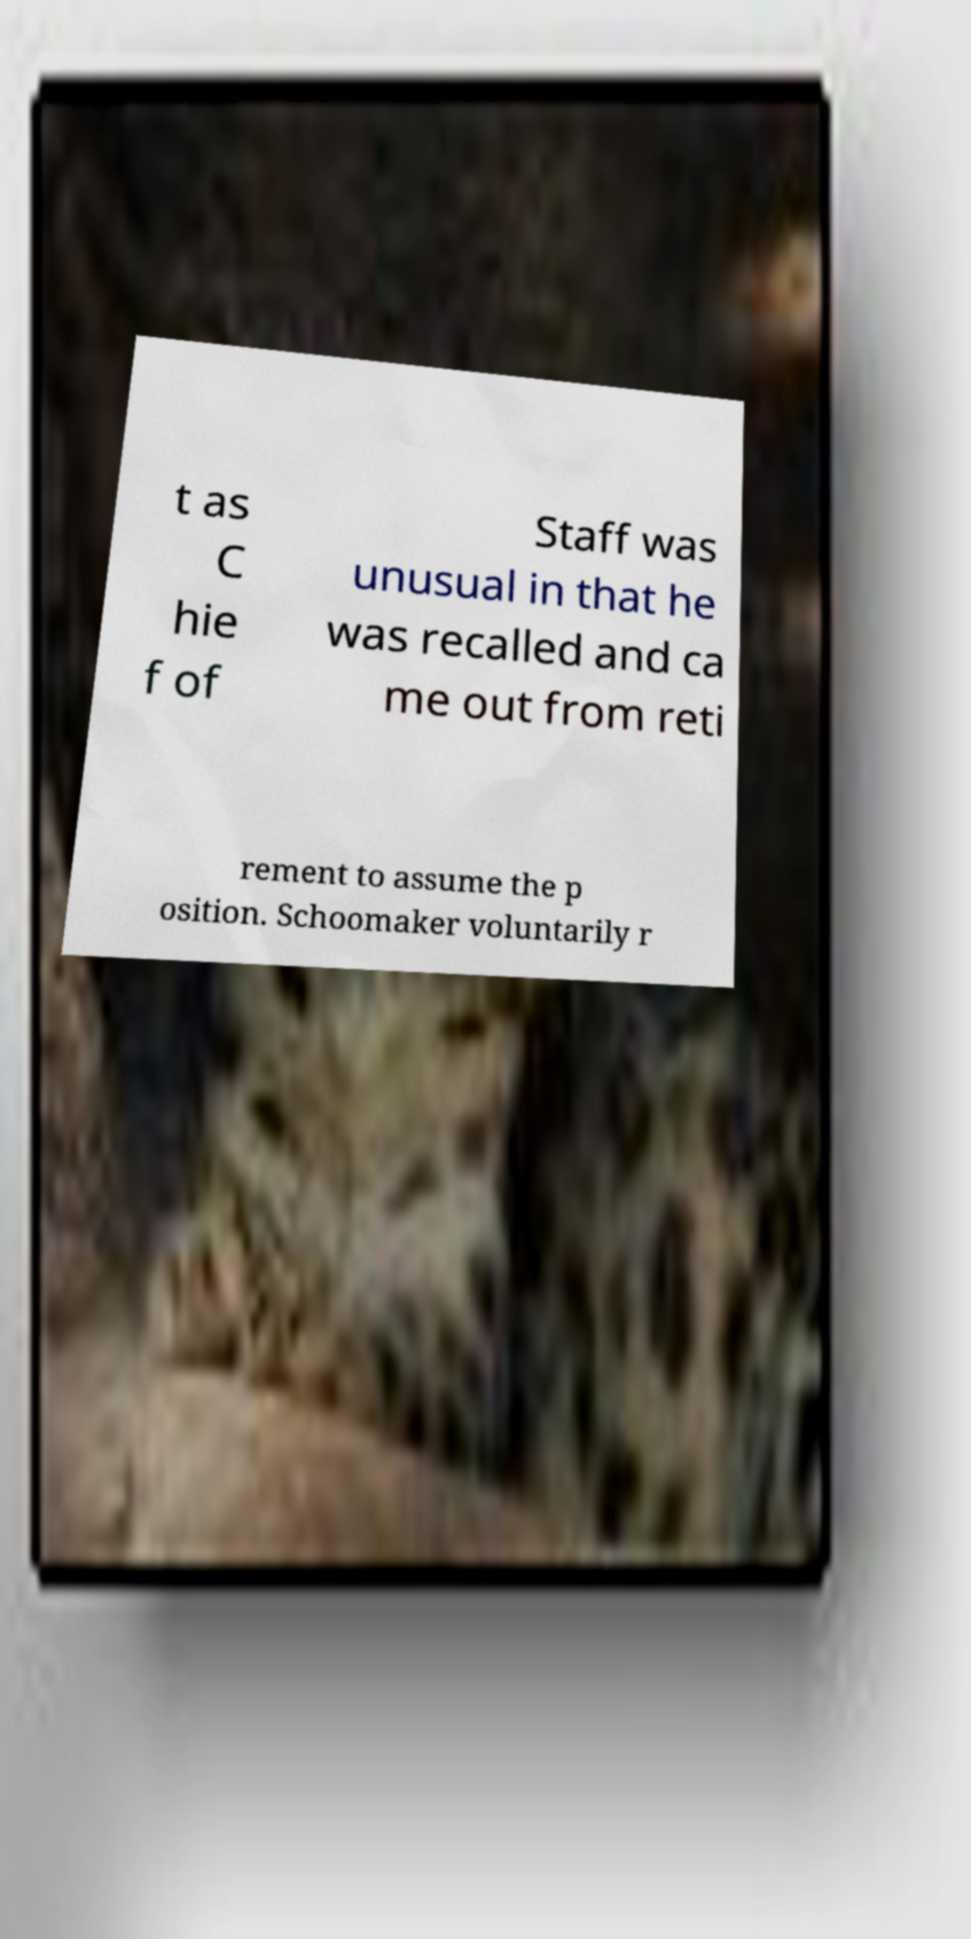Please identify and transcribe the text found in this image. t as C hie f of Staff was unusual in that he was recalled and ca me out from reti rement to assume the p osition. Schoomaker voluntarily r 